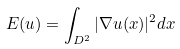<formula> <loc_0><loc_0><loc_500><loc_500>E ( u ) = \int _ { D ^ { 2 } } | \nabla u ( x ) | ^ { 2 } d x</formula> 